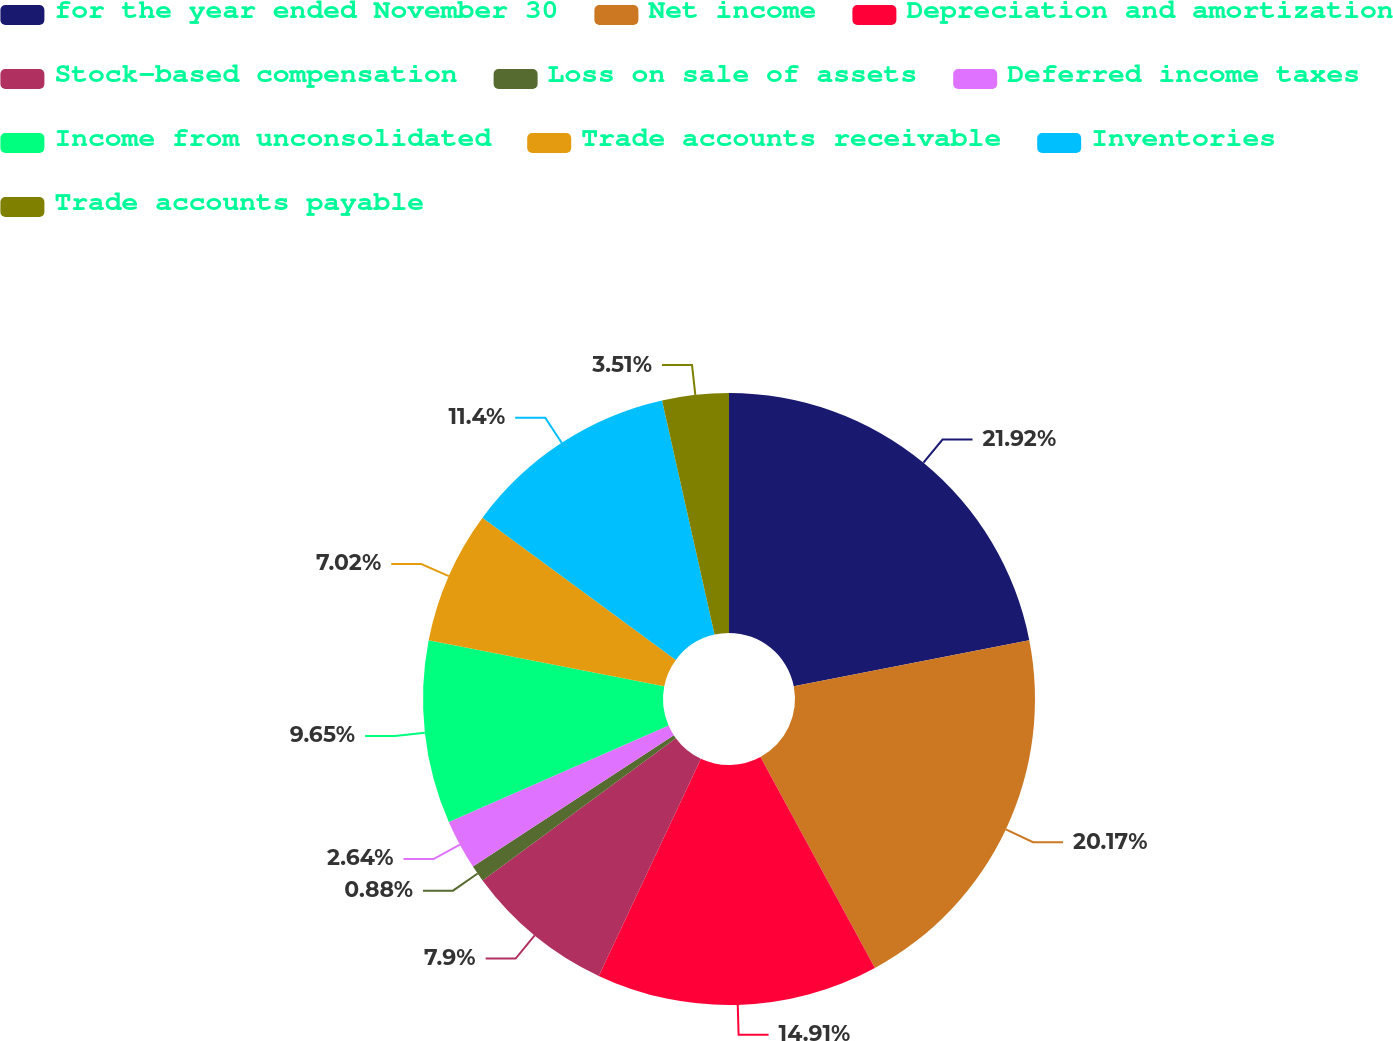Convert chart. <chart><loc_0><loc_0><loc_500><loc_500><pie_chart><fcel>for the year ended November 30<fcel>Net income<fcel>Depreciation and amortization<fcel>Stock-based compensation<fcel>Loss on sale of assets<fcel>Deferred income taxes<fcel>Income from unconsolidated<fcel>Trade accounts receivable<fcel>Inventories<fcel>Trade accounts payable<nl><fcel>21.92%<fcel>20.17%<fcel>14.91%<fcel>7.9%<fcel>0.88%<fcel>2.64%<fcel>9.65%<fcel>7.02%<fcel>11.4%<fcel>3.51%<nl></chart> 